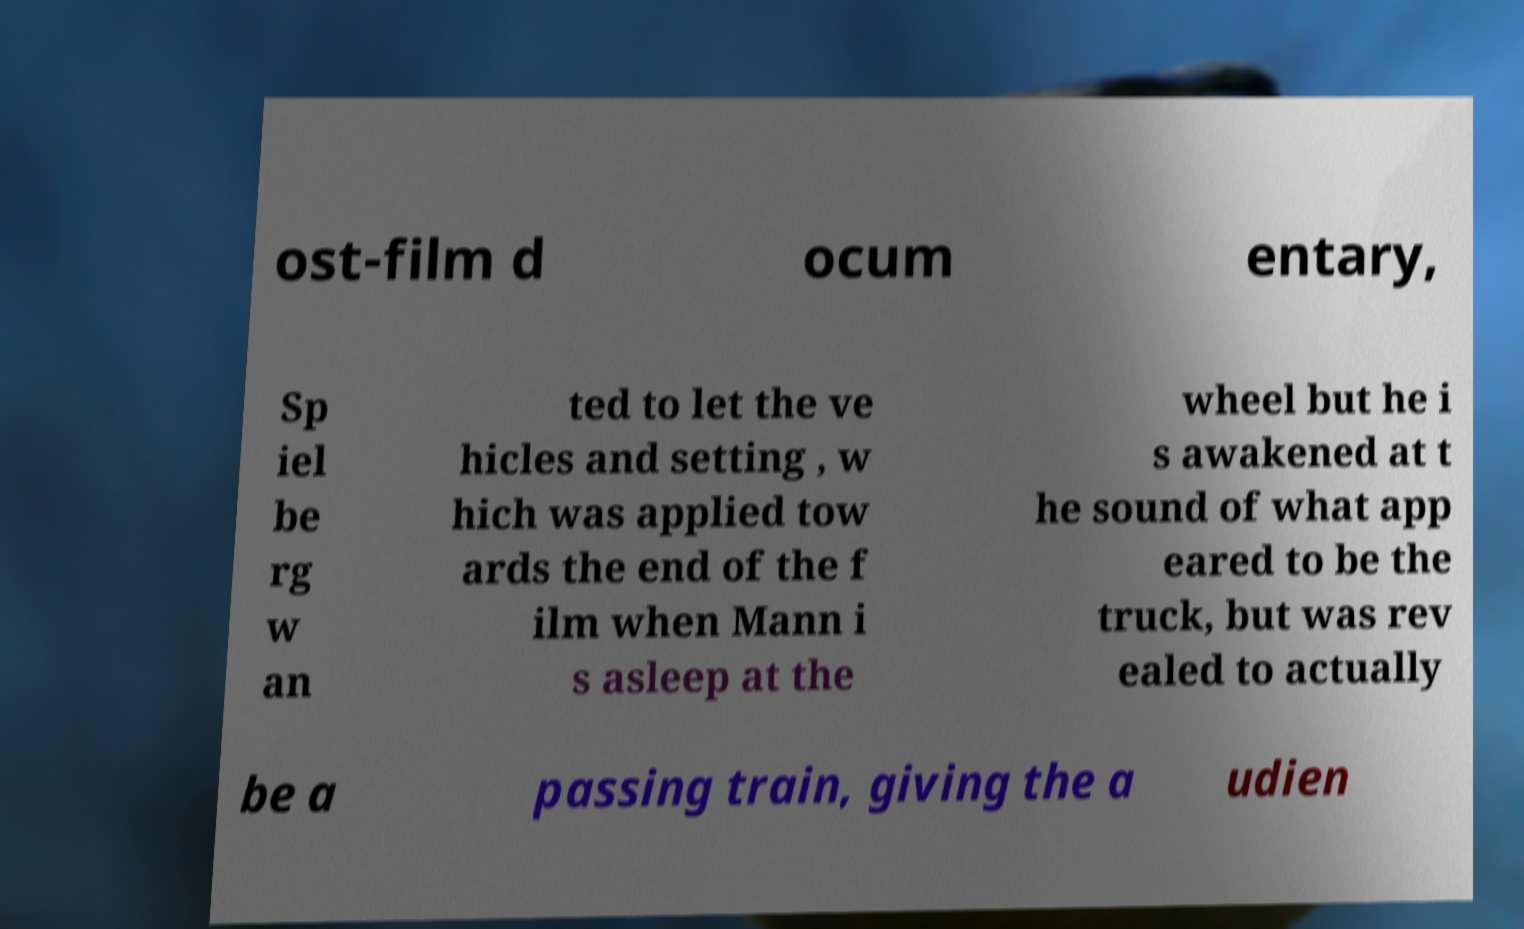Please read and relay the text visible in this image. What does it say? ost-film d ocum entary, Sp iel be rg w an ted to let the ve hicles and setting , w hich was applied tow ards the end of the f ilm when Mann i s asleep at the wheel but he i s awakened at t he sound of what app eared to be the truck, but was rev ealed to actually be a passing train, giving the a udien 